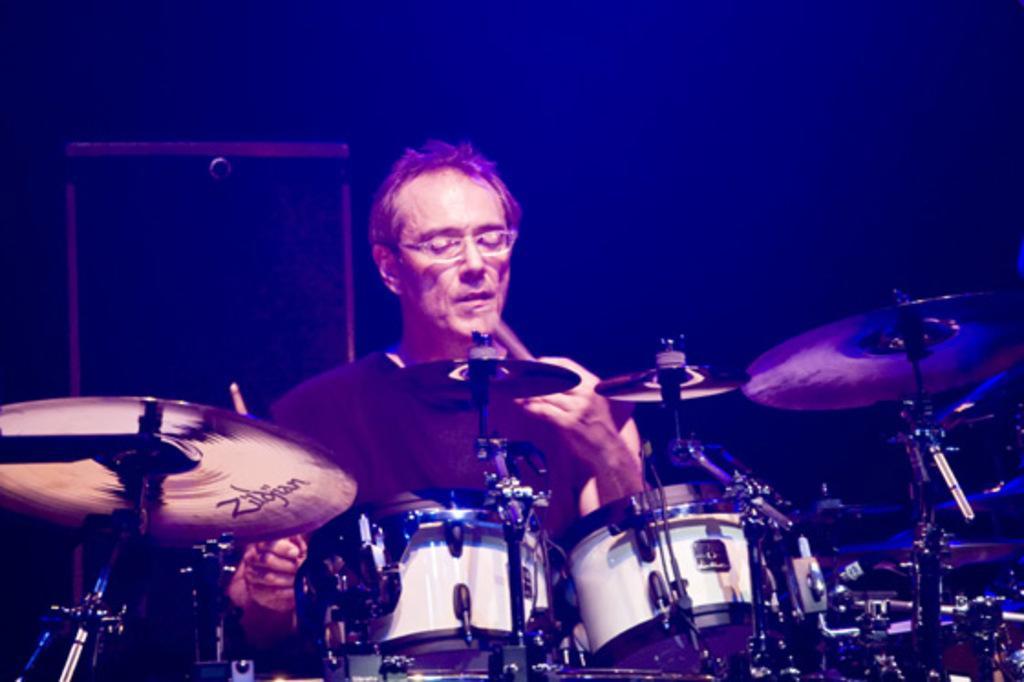Describe this image in one or two sentences. In this image we can see a man is sitting and playing drums. Behind rectangular shape things is there. 